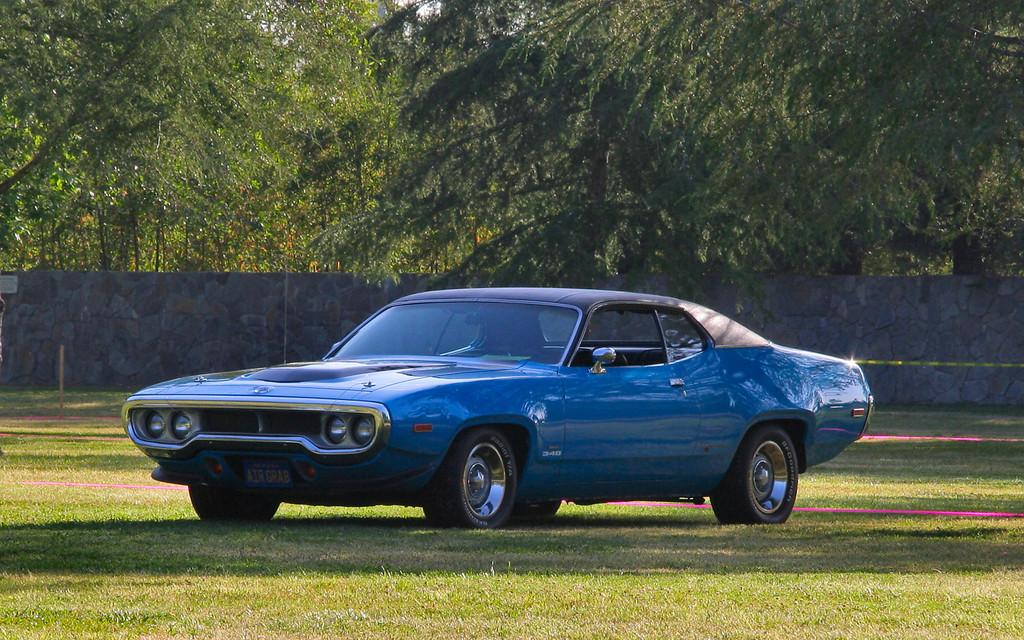What color is the car in the image? The car in the image is blue. Where is the car located in the image? The car is on the grass. What can be seen in the background of the image? There are trees and a wall in the background of the image. What type of animal is involved in the discussion in the image? There is no animal or discussion present in the image; it features a blue car on the grass with trees and a wall in the background. 